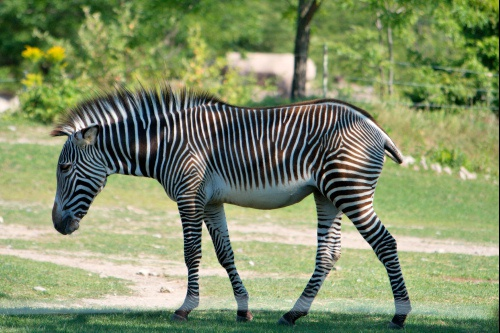Describe the objects in this image and their specific colors. I can see a zebra in darkgreen, black, gray, and darkgray tones in this image. 